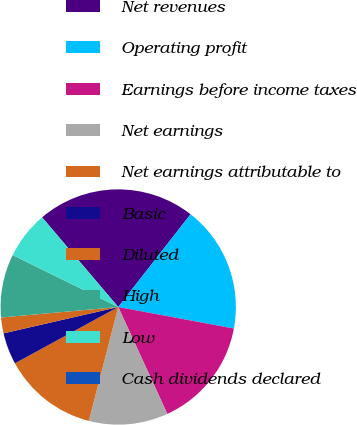<chart> <loc_0><loc_0><loc_500><loc_500><pie_chart><fcel>Net revenues<fcel>Operating profit<fcel>Earnings before income taxes<fcel>Net earnings<fcel>Net earnings attributable to<fcel>Basic<fcel>Diluted<fcel>High<fcel>Low<fcel>Cash dividends declared<nl><fcel>21.74%<fcel>17.39%<fcel>15.22%<fcel>10.87%<fcel>13.04%<fcel>4.35%<fcel>2.17%<fcel>8.7%<fcel>6.52%<fcel>0.0%<nl></chart> 